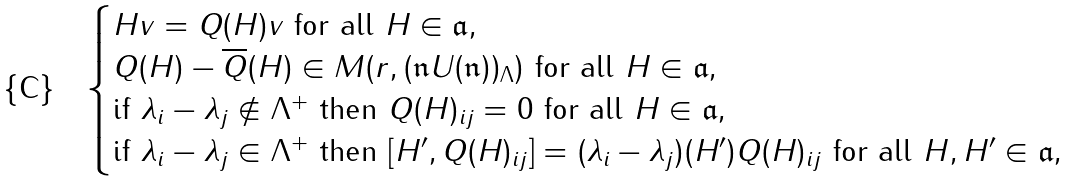<formula> <loc_0><loc_0><loc_500><loc_500>\begin{cases} \text {$Hv = Q(H)v$ for all $H\in \mathfrak{a}$} , \\ \text {$Q(H) - \overline{Q}(H)\in M(r,(\mathfrak{n}U(\mathfrak{n}))_{\Lambda})$ for all $H\in\mathfrak{a}$} , \\ \text {if $\lambda_{i} - \lambda_{j} \not\in\Lambda^{+}$ then $Q(H)_{ij} = 0$ for all $H\in \mathfrak{a}$} , \\ \text {if $\lambda_{i} - \lambda_{j} \in \Lambda^{+}$ then $[H^{\prime},Q(H)_{ij}] = (\lambda_{i} - \lambda_{j})(H^{\prime})Q(H)_{ij}$ for all $H,H^{\prime}\in \mathfrak{a}$} , \end{cases}</formula> 